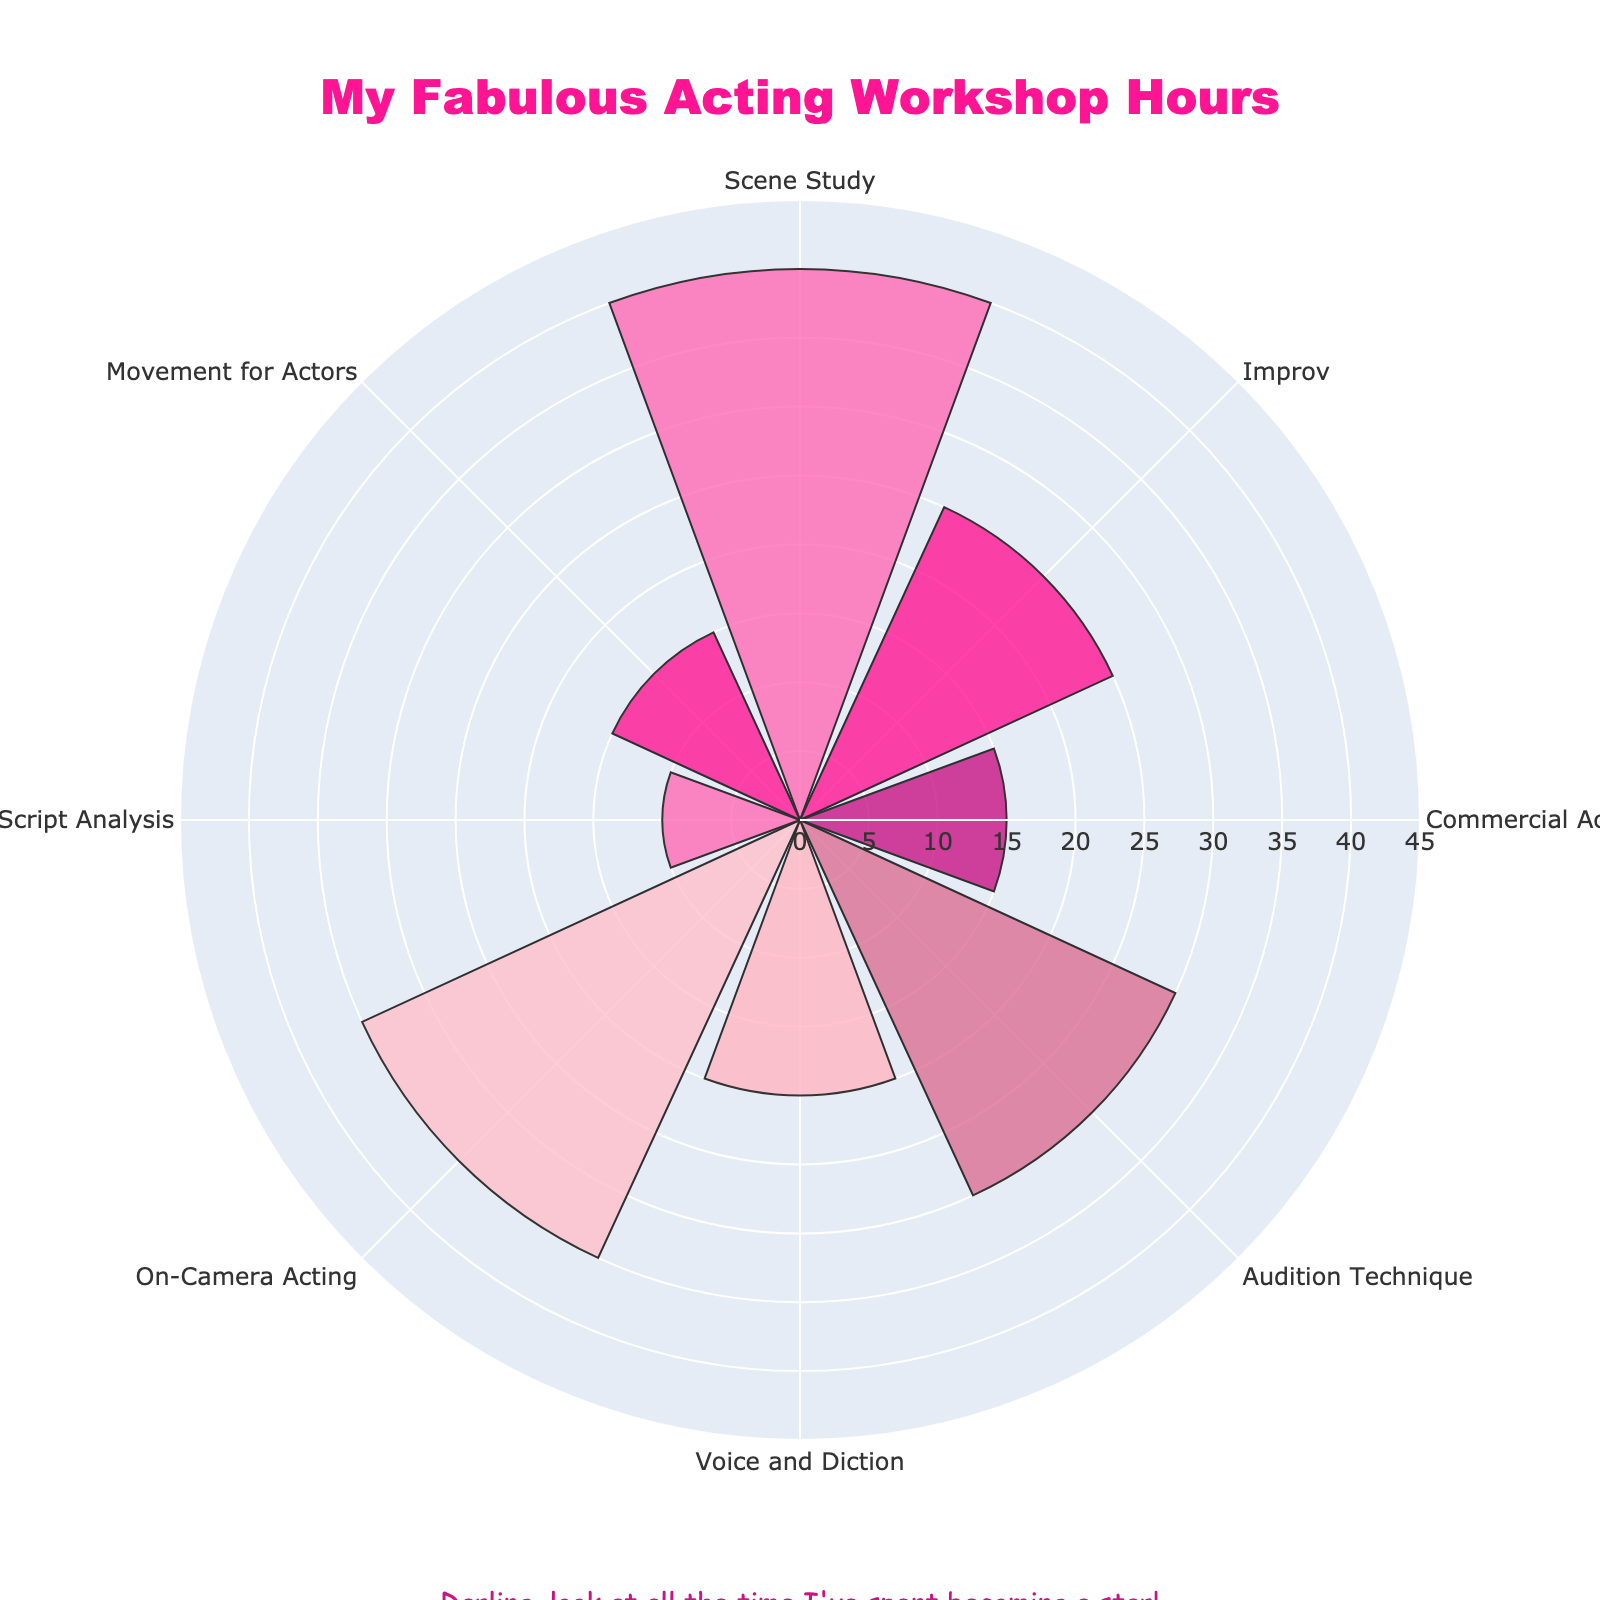How many different acting workshops are represented in the chart? Count the number of distinct labels present in the chart. Each label corresponds to a different acting workshop.
Answer: 8 Which workshop has the highest number of hours? Look for the longest bar in the chart. The workshop with the longest bar represents the highest number of hours.
Answer: Scene Study By how many hours does On-Camera Acting exceed Commercial Acting? Find the bar lengths for On-Camera Acting and Commercial Acting; subtract the number of hours for Commercial Acting from On-Camera Acting (35 - 15).
Answer: 20 What is the total number of hours spent on Voice and Diction and Movement for Actors combined? Add the hours for Voice and Diction and Movement for Actors (20 + 15).
Answer: 35 Which workshop has the shortest number of hours, and how many? Identify the shortest bar in the chart. The workshop with the shortest bar represents the fewest hours, and note the number of hours from this bar.
Answer: Script Analysis, 10 Rank the workshops in descending order of hours spent. List the workshops from the one with the highest number of hours to the one with the fewest. Check the radial lengths for each workshop and sort them accordingly.
Answer: Scene Study, On-Camera Acting, Audition Technique, Improv, Voice and Diction, Commercial Acting and Movement for Actors, Script Analysis Is the combined time spent on Improv and Audition Technique greater than the time spent on Scene Study? Add the hours for Improv and Audition Technique and compare the sum to the hours for Scene Study (25 + 30 > 40).
Answer: Yes What percentage of total workshop hours is spent on Audition Technique? Calculate the total hours spent on all workshops, find the hours for Audition Technique, divide them by the total hours, and multiply by 100 ((30 / (40 + 25 + 15 + 30 + 20 + 35 + 10 + 15)) * 100).
Answer: 14.71% Do more hours get spent on Commercial Acting or Movement for Actors? Compare the radial lengths of the two bars corresponding to Commercial Acting and Movement for Actors to see which one is longer.
Answer: Same 